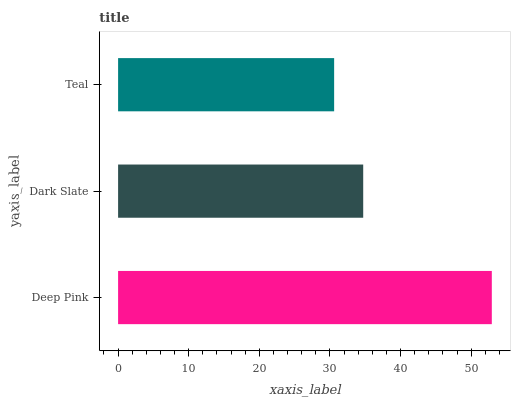Is Teal the minimum?
Answer yes or no. Yes. Is Deep Pink the maximum?
Answer yes or no. Yes. Is Dark Slate the minimum?
Answer yes or no. No. Is Dark Slate the maximum?
Answer yes or no. No. Is Deep Pink greater than Dark Slate?
Answer yes or no. Yes. Is Dark Slate less than Deep Pink?
Answer yes or no. Yes. Is Dark Slate greater than Deep Pink?
Answer yes or no. No. Is Deep Pink less than Dark Slate?
Answer yes or no. No. Is Dark Slate the high median?
Answer yes or no. Yes. Is Dark Slate the low median?
Answer yes or no. Yes. Is Deep Pink the high median?
Answer yes or no. No. Is Teal the low median?
Answer yes or no. No. 